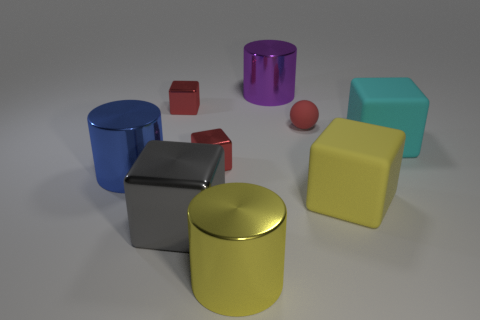How big is the red metal cube behind the tiny red matte thing?
Offer a very short reply. Small. Are there any blue balls made of the same material as the yellow cube?
Ensure brevity in your answer.  No. Is the big blue cylinder made of the same material as the cyan object?
Your response must be concise. No. There is a metallic block that is the same size as the purple metallic cylinder; what color is it?
Give a very brief answer. Gray. What number of other objects are there of the same shape as the yellow metal object?
Offer a very short reply. 2. Is the size of the red rubber ball the same as the yellow object that is in front of the large gray object?
Your answer should be very brief. No. What number of things are either small blue objects or small metal things?
Your answer should be compact. 2. What number of other things are there of the same size as the gray object?
Offer a terse response. 5. There is a large metal cube; does it have the same color as the cube that is behind the small red ball?
Keep it short and to the point. No. What number of spheres are either cyan matte objects or big purple metallic objects?
Give a very brief answer. 0. 